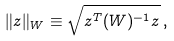<formula> <loc_0><loc_0><loc_500><loc_500>\| z \| _ { W } \equiv \sqrt { z ^ { T } ( W ) ^ { - 1 } z } \, ,</formula> 